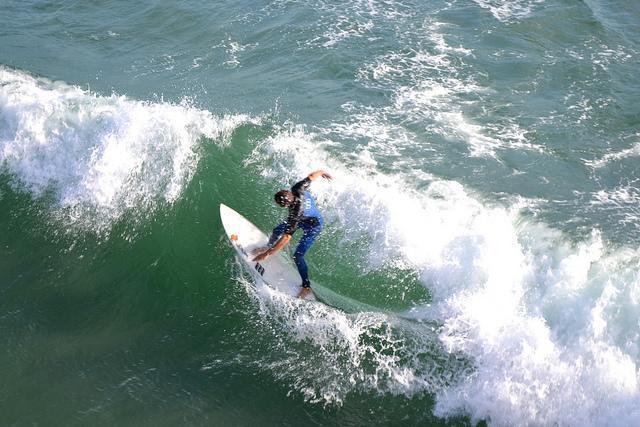How many people can be seen?
Give a very brief answer. 1. 